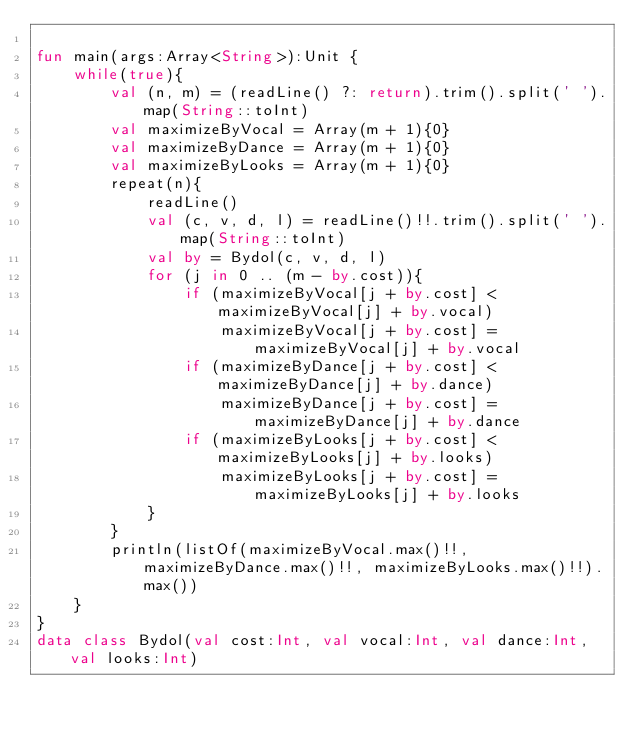Convert code to text. <code><loc_0><loc_0><loc_500><loc_500><_Kotlin_>
fun main(args:Array<String>):Unit {
    while(true){
        val (n, m) = (readLine() ?: return).trim().split(' ').map(String::toInt)
        val maximizeByVocal = Array(m + 1){0}
        val maximizeByDance = Array(m + 1){0}
        val maximizeByLooks = Array(m + 1){0}
        repeat(n){
            readLine()
            val (c, v, d, l) = readLine()!!.trim().split(' ').map(String::toInt)
            val by = Bydol(c, v, d, l)
            for (j in 0 .. (m - by.cost)){
                if (maximizeByVocal[j + by.cost] < maximizeByVocal[j] + by.vocal)
                    maximizeByVocal[j + by.cost] = maximizeByVocal[j] + by.vocal
                if (maximizeByDance[j + by.cost] < maximizeByDance[j] + by.dance)
                    maximizeByDance[j + by.cost] = maximizeByDance[j] + by.dance
                if (maximizeByLooks[j + by.cost] < maximizeByLooks[j] + by.looks)
                    maximizeByLooks[j + by.cost] = maximizeByLooks[j] + by.looks
            }
        }
        println(listOf(maximizeByVocal.max()!!, maximizeByDance.max()!!, maximizeByLooks.max()!!).max())
    }
}
data class Bydol(val cost:Int, val vocal:Int, val dance:Int, val looks:Int)
</code> 